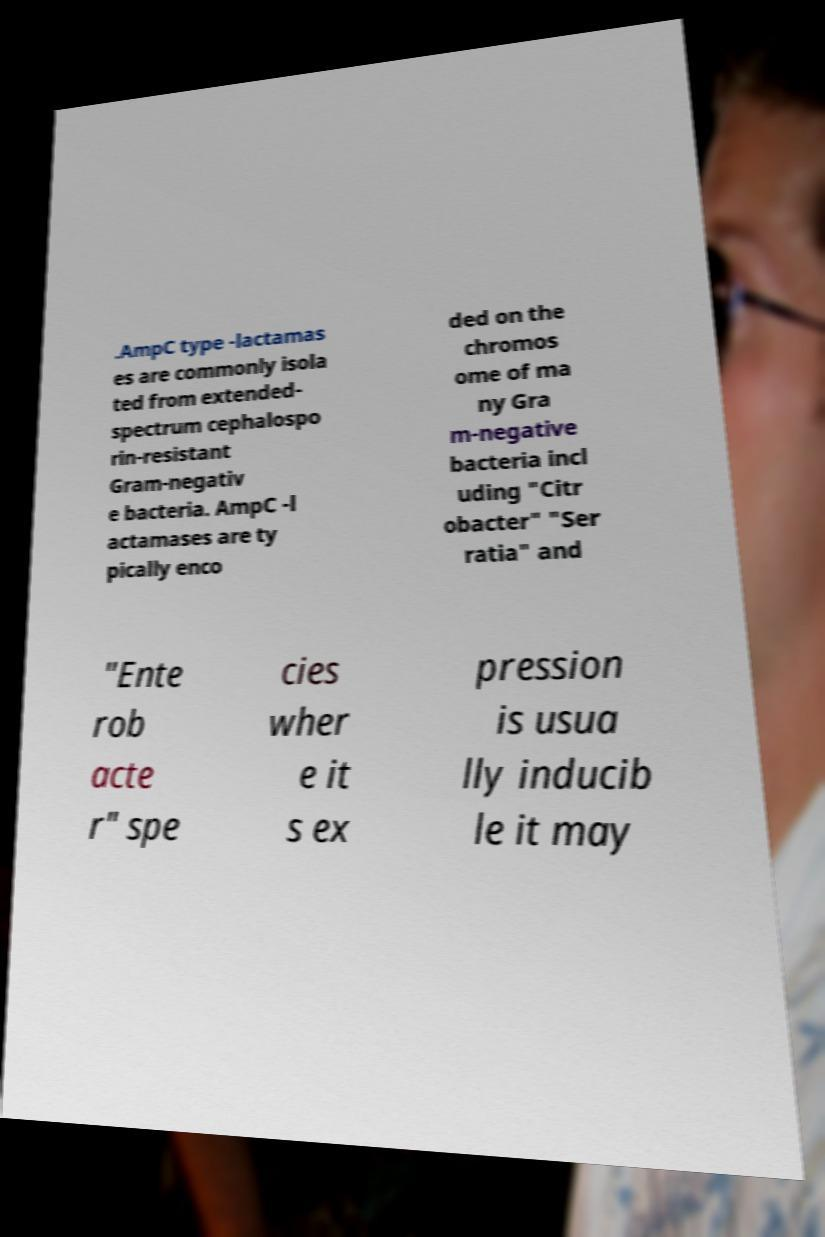For documentation purposes, I need the text within this image transcribed. Could you provide that? .AmpC type -lactamas es are commonly isola ted from extended- spectrum cephalospo rin-resistant Gram-negativ e bacteria. AmpC -l actamases are ty pically enco ded on the chromos ome of ma ny Gra m-negative bacteria incl uding "Citr obacter" "Ser ratia" and "Ente rob acte r" spe cies wher e it s ex pression is usua lly inducib le it may 